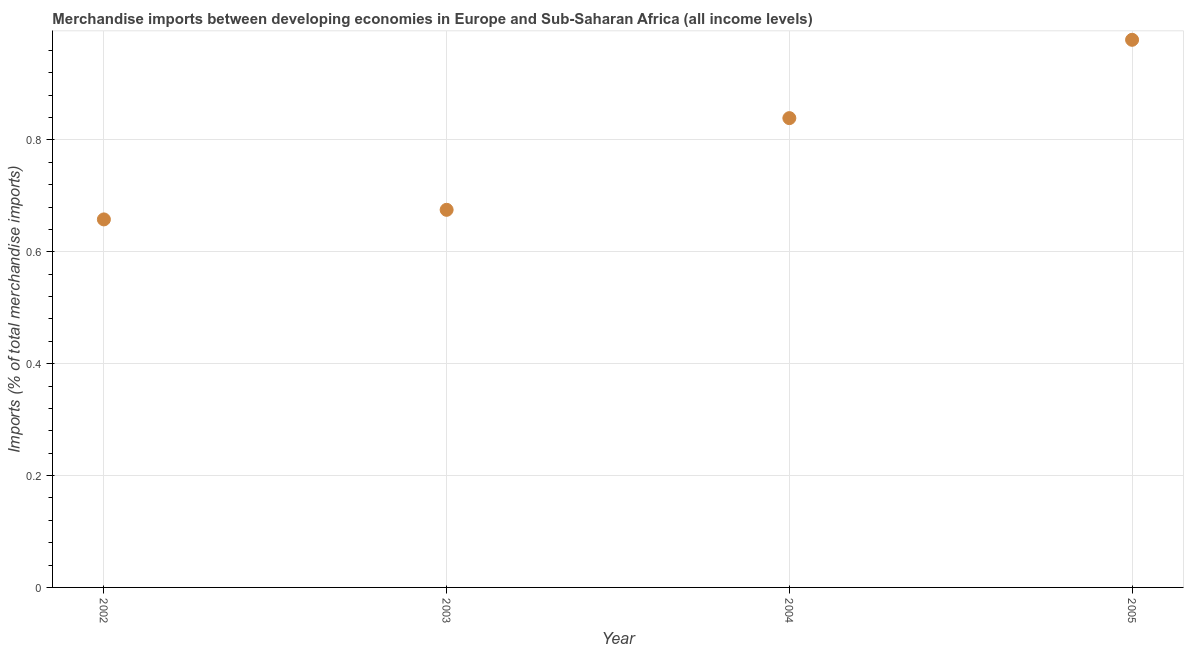What is the merchandise imports in 2005?
Offer a terse response. 0.98. Across all years, what is the maximum merchandise imports?
Provide a succinct answer. 0.98. Across all years, what is the minimum merchandise imports?
Provide a short and direct response. 0.66. In which year was the merchandise imports minimum?
Your response must be concise. 2002. What is the sum of the merchandise imports?
Provide a short and direct response. 3.15. What is the difference between the merchandise imports in 2002 and 2004?
Make the answer very short. -0.18. What is the average merchandise imports per year?
Ensure brevity in your answer.  0.79. What is the median merchandise imports?
Offer a terse response. 0.76. In how many years, is the merchandise imports greater than 0.44 %?
Ensure brevity in your answer.  4. What is the ratio of the merchandise imports in 2004 to that in 2005?
Your answer should be very brief. 0.86. Is the merchandise imports in 2002 less than that in 2004?
Make the answer very short. Yes. What is the difference between the highest and the second highest merchandise imports?
Make the answer very short. 0.14. Is the sum of the merchandise imports in 2002 and 2004 greater than the maximum merchandise imports across all years?
Your response must be concise. Yes. What is the difference between the highest and the lowest merchandise imports?
Your answer should be compact. 0.32. In how many years, is the merchandise imports greater than the average merchandise imports taken over all years?
Offer a very short reply. 2. How many years are there in the graph?
Offer a very short reply. 4. What is the difference between two consecutive major ticks on the Y-axis?
Offer a very short reply. 0.2. What is the title of the graph?
Your response must be concise. Merchandise imports between developing economies in Europe and Sub-Saharan Africa (all income levels). What is the label or title of the X-axis?
Your answer should be very brief. Year. What is the label or title of the Y-axis?
Give a very brief answer. Imports (% of total merchandise imports). What is the Imports (% of total merchandise imports) in 2002?
Keep it short and to the point. 0.66. What is the Imports (% of total merchandise imports) in 2003?
Ensure brevity in your answer.  0.68. What is the Imports (% of total merchandise imports) in 2004?
Ensure brevity in your answer.  0.84. What is the Imports (% of total merchandise imports) in 2005?
Keep it short and to the point. 0.98. What is the difference between the Imports (% of total merchandise imports) in 2002 and 2003?
Make the answer very short. -0.02. What is the difference between the Imports (% of total merchandise imports) in 2002 and 2004?
Provide a short and direct response. -0.18. What is the difference between the Imports (% of total merchandise imports) in 2002 and 2005?
Keep it short and to the point. -0.32. What is the difference between the Imports (% of total merchandise imports) in 2003 and 2004?
Your answer should be compact. -0.16. What is the difference between the Imports (% of total merchandise imports) in 2003 and 2005?
Keep it short and to the point. -0.3. What is the difference between the Imports (% of total merchandise imports) in 2004 and 2005?
Give a very brief answer. -0.14. What is the ratio of the Imports (% of total merchandise imports) in 2002 to that in 2003?
Give a very brief answer. 0.97. What is the ratio of the Imports (% of total merchandise imports) in 2002 to that in 2004?
Make the answer very short. 0.78. What is the ratio of the Imports (% of total merchandise imports) in 2002 to that in 2005?
Offer a very short reply. 0.67. What is the ratio of the Imports (% of total merchandise imports) in 2003 to that in 2004?
Your answer should be very brief. 0.81. What is the ratio of the Imports (% of total merchandise imports) in 2003 to that in 2005?
Offer a terse response. 0.69. What is the ratio of the Imports (% of total merchandise imports) in 2004 to that in 2005?
Make the answer very short. 0.86. 